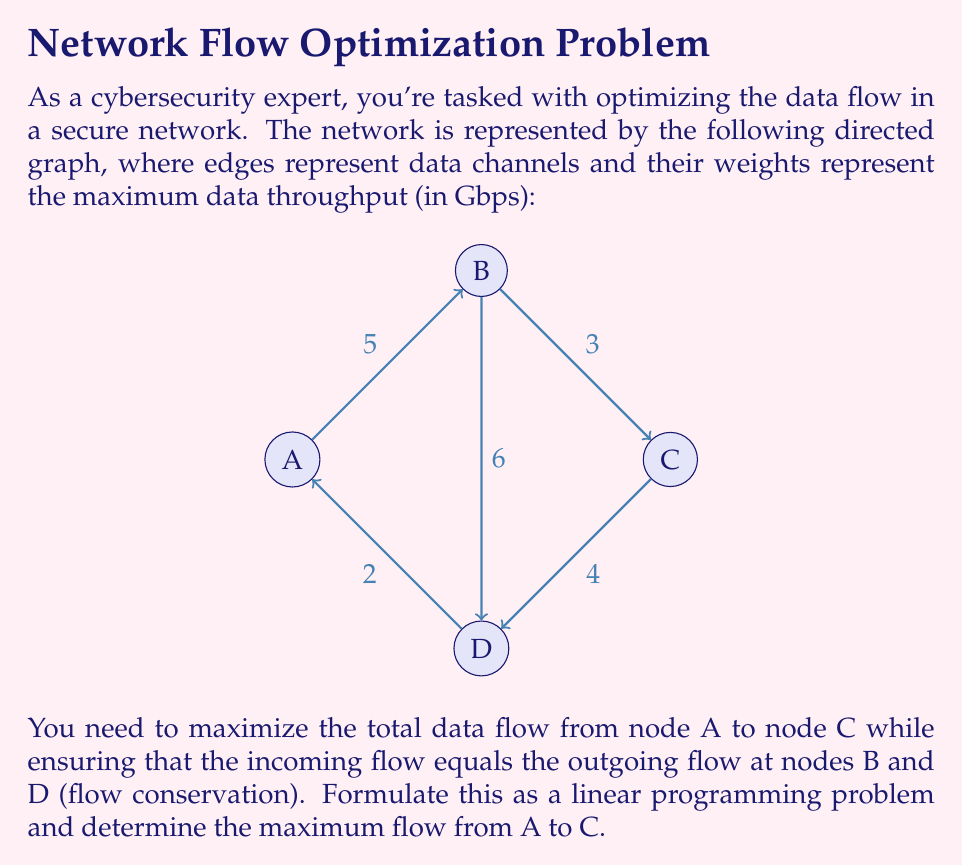Solve this math problem. To solve this problem, we'll use the max-flow formulation in linear programming:

1) Define variables:
   Let $x_{ij}$ be the flow from node i to node j.

2) Objective function:
   Maximize the flow from A to C:
   $$\text{Maximize } x_{AB} + x_{AD}$$

3) Constraints:
   a) Capacity constraints:
      $$0 \leq x_{AB} \leq 5$$
      $$0 \leq x_{AD} \leq 2$$
      $$0 \leq x_{BC} \leq 3$$
      $$0 \leq x_{BD} \leq 6$$
      $$0 \leq x_{DC} \leq 4$$

   b) Flow conservation at B:
      $$x_{AB} = x_{BC} + x_{BD}$$

   c) Flow conservation at D:
      $$x_{AD} + x_{BD} = x_{DC}$$

4) Solve the linear program:
   We can solve this using the simplex method or an LP solver. The optimal solution is:
   $$x_{AB} = 5, x_{AD} = 2, x_{BC} = 3, x_{BD} = 2, x_{DC} = 4$$

5) Calculate the maximum flow:
   The maximum flow from A to C is the sum of flows on all paths from A to C:
   $$\text{Max Flow} = x_{BC} + x_{DC} = 3 + 4 = 7$$

Therefore, the maximum data flow from node A to node C is 7 Gbps.
Answer: 7 Gbps 